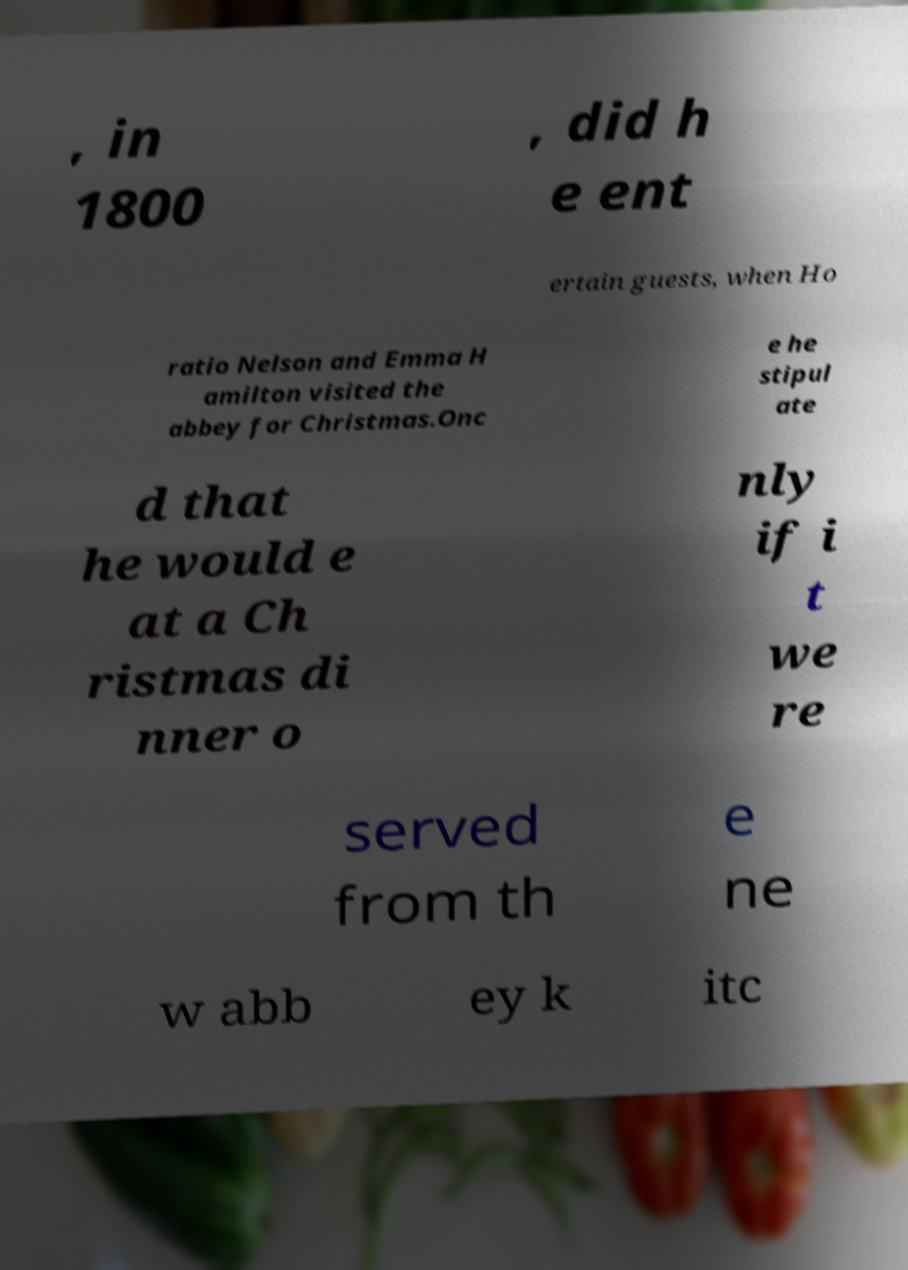Can you accurately transcribe the text from the provided image for me? , in 1800 , did h e ent ertain guests, when Ho ratio Nelson and Emma H amilton visited the abbey for Christmas.Onc e he stipul ate d that he would e at a Ch ristmas di nner o nly if i t we re served from th e ne w abb ey k itc 